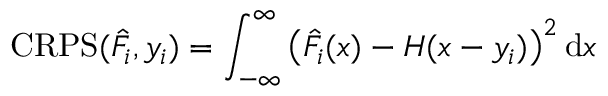<formula> <loc_0><loc_0><loc_500><loc_500>C R P S ( \hat { F } _ { i } , y _ { i } ) = \int _ { - \infty } ^ { \infty } \left ( \hat { F } _ { i } ( x ) - H ( x - y _ { i } ) \right ) ^ { 2 } d x</formula> 